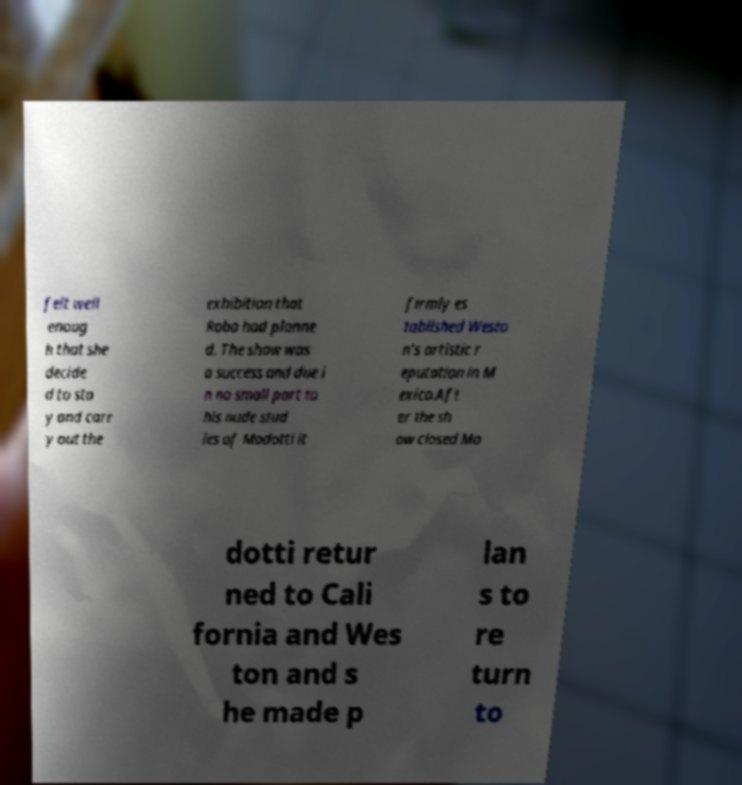Can you read and provide the text displayed in the image?This photo seems to have some interesting text. Can you extract and type it out for me? felt well enoug h that she decide d to sta y and carr y out the exhibition that Robo had planne d. The show was a success and due i n no small part to his nude stud ies of Modotti it firmly es tablished Westo n's artistic r eputation in M exico.Aft er the sh ow closed Mo dotti retur ned to Cali fornia and Wes ton and s he made p lan s to re turn to 